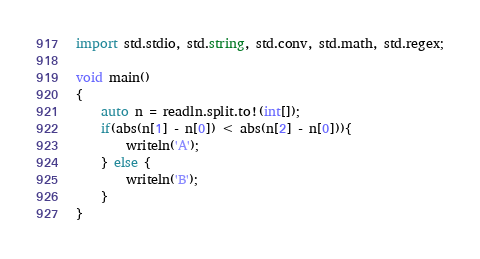<code> <loc_0><loc_0><loc_500><loc_500><_D_>import std.stdio, std.string, std.conv, std.math, std.regex;

void main()
{
	auto n = readln.split.to!(int[]);
	if(abs(n[1] - n[0]) < abs(n[2] - n[0])){
		writeln('A');
	} else {
		writeln('B');
	}
}</code> 